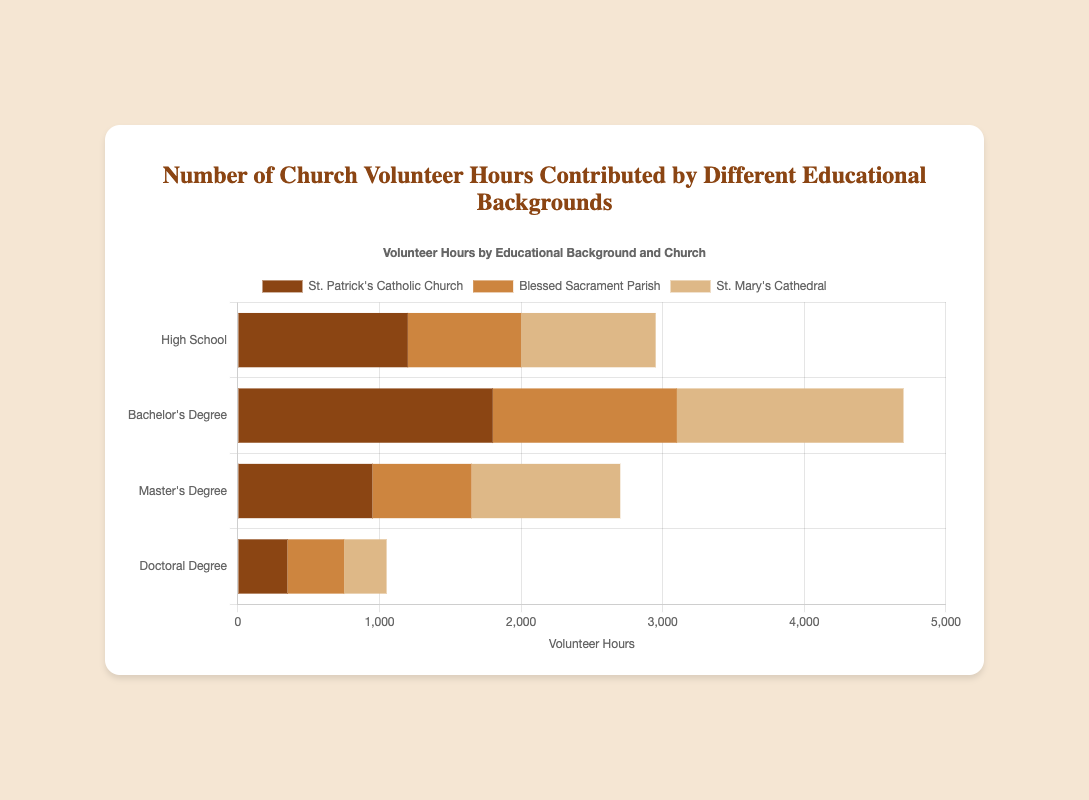What is the total number of volunteer hours contributed by people with a Bachelor's Degree across all churches? To find the total number of volunteer hours contributed by people with a Bachelor's Degree, sum the hours listed for St. Patrick's Catholic Church (1800), Blessed Sacrament Parish (1300), and St. Mary's Cathedral (1600). Therefore, the total is 1800 + 1300 + 1600 = 4700 hours.
Answer: 4700 Which church had the highest number of volunteer hours contributed by individuals with a High School background? Compare the volunteer hours for each church in the High School category: St. Patrick's Catholic Church (1200), Blessed Sacrament Parish (800), and St. Mary's Cathedral (950). St. Patrick's Catholic Church has the highest with 1200 hours.
Answer: St. Patrick's Catholic Church Which educational background has the least total volunteer hours overall? Sum the volunteer hours for each educational background across all churches. High School has 1200 + 800 + 950 = 2950 hours, Bachelor's Degree has 1800 + 1300 + 1600 = 4700 hours, Master's Degree has 950 + 700 + 1050 = 2700 hours, and Doctoral Degree has 350 + 400 + 300 = 1050 hours. Doctoral Degree has the least with 1050 hours.
Answer: Doctoral Degree How many more volunteer hours were contributed by individuals with a Master's Degree than a Doctoral Degree at St. Mary's Cathedral? At St. Mary's Cathedral, Master’s Degree holders contributed 1050 hours, while Doctoral Degree holders contributed 300 hours. The difference is 1050 - 300 = 750 hours more.
Answer: 750 Which visual attributes can be used to identify St. Patrick's Catholic Church's contributions across different educational backgrounds? St. Patrick's Catholic Church's contributions can be identified by the color of the bars, which are brown.
Answer: brown What is the average number of volunteer hours contributed by High School background individuals across all churches? Sum the volunteer hours for High School individuals: 1200 (St. Patrick's Catholic Church) + 800 (Blessed Sacrament Parish) + 950 (St. Mary's Cathedral) = 2950. There are 3 data points, so the average is 2950 / 3 = 983.33 hours.
Answer: 983.33 Is there any church where the volunteer hours contributed by Bachelor’s Degree holders are less than those contributed by High School holders? Compare the hours: St. Patrick's Catholic Church (Bachelor's: 1800, High School: 1200), Blessed Sacrament Parish (Bachelor's: 1300, High School: 800), and St. Mary's Cathedral (Bachelor's: 1600, High School: 950). In all cases, Bachelor's Degree holders contributed more.
Answer: No Which educational background contributed the most volunteer hours at Blessed Sacrament Parish? Compare the volunteer hours at Blessed Sacrament Parish: High School (800), Bachelor’s Degree (1300), Master’s Degree (700), Doctoral Degree (400). Bachelor's Degree holders contributed the most with 1300 hours.
Answer: Bachelor’s Degree Between St. Mary's Cathedral and Blessed Sacrament Parish, which one had more volunteer hours contributed by individuals with a High School background? Compare the hours: St. Mary's Cathedral (950) and Blessed Sacrament Parish (800). St. Mary's Cathedral has more with 950 hours.
Answer: St. Mary's Cathedral 